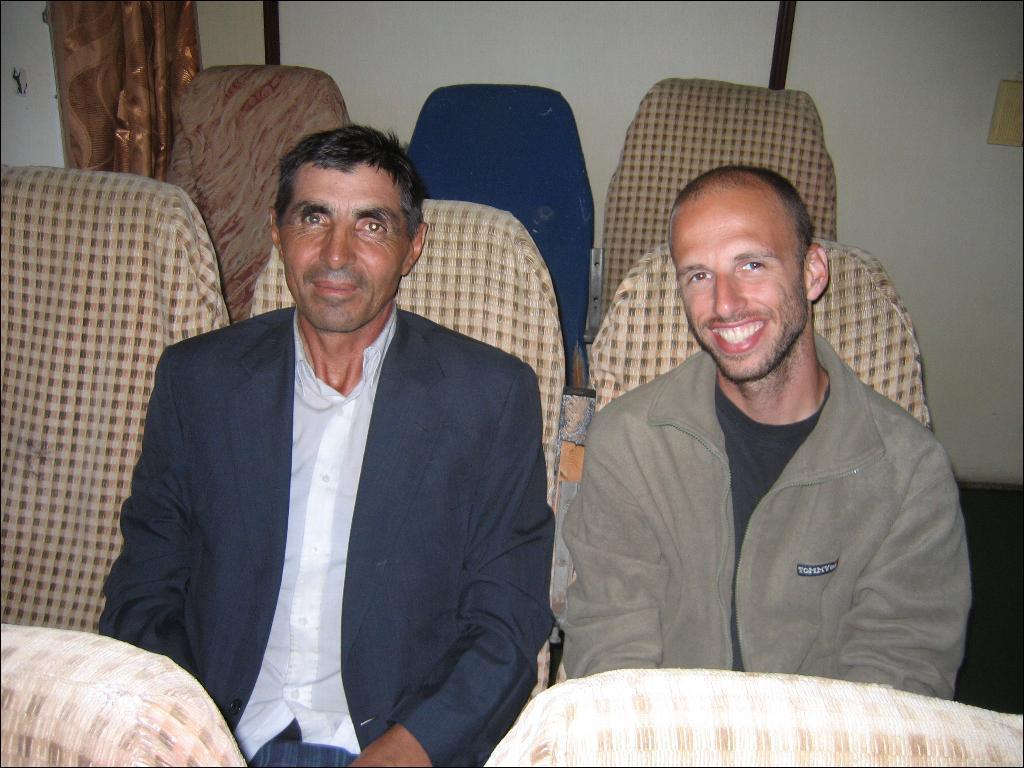What are the men in the image doing? The men in the image are sitting on chairs. What can be seen in the background of the image? There are walls and a curtain in the background of the image. What is the rate of regret experienced by the men in the image? There is no indication of regret or any emotions in the image, so it cannot be determined. 